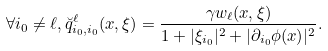<formula> <loc_0><loc_0><loc_500><loc_500>\forall i _ { 0 } \neq \ell , \breve { q } ^ { \ell } _ { i _ { 0 } , i _ { 0 } } ( x , \xi ) = \frac { \gamma w _ { \ell } ( x , \xi ) } { 1 + | \xi _ { i _ { 0 } } | ^ { 2 } + | \partial _ { i _ { 0 } } \phi ( x ) | ^ { 2 } } .</formula> 